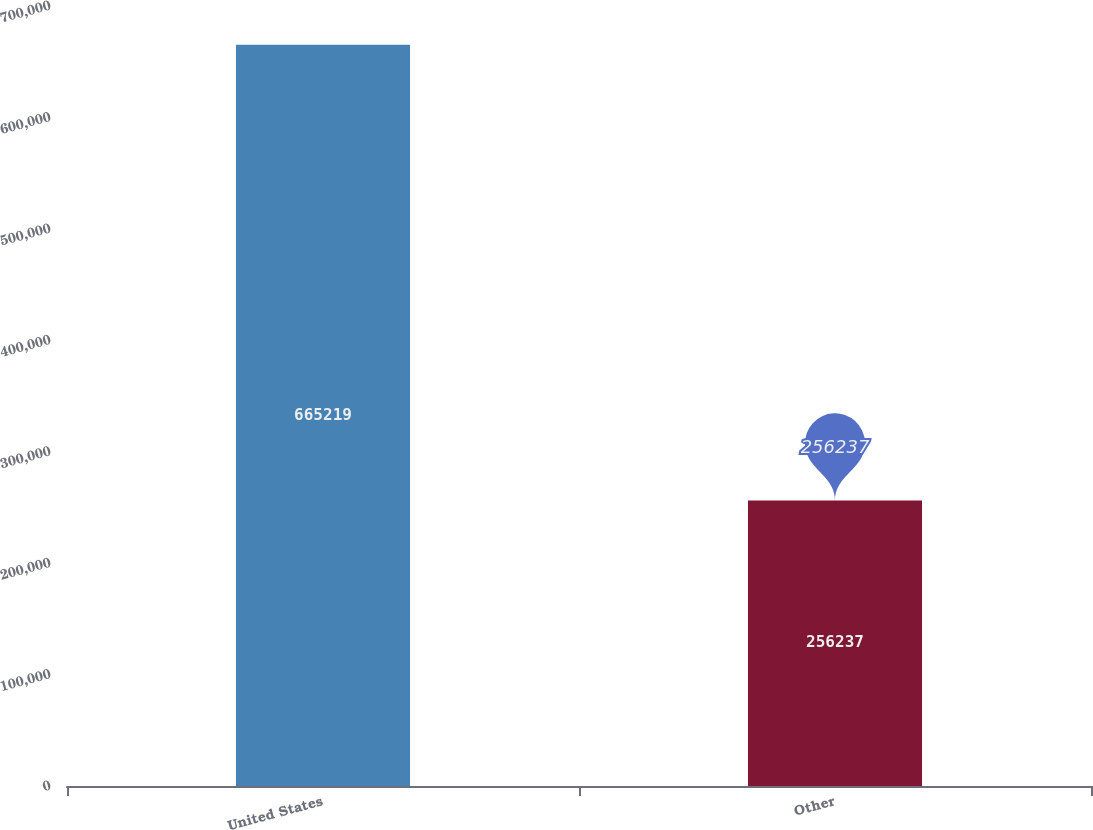<chart> <loc_0><loc_0><loc_500><loc_500><bar_chart><fcel>United States<fcel>Other<nl><fcel>665219<fcel>256237<nl></chart> 